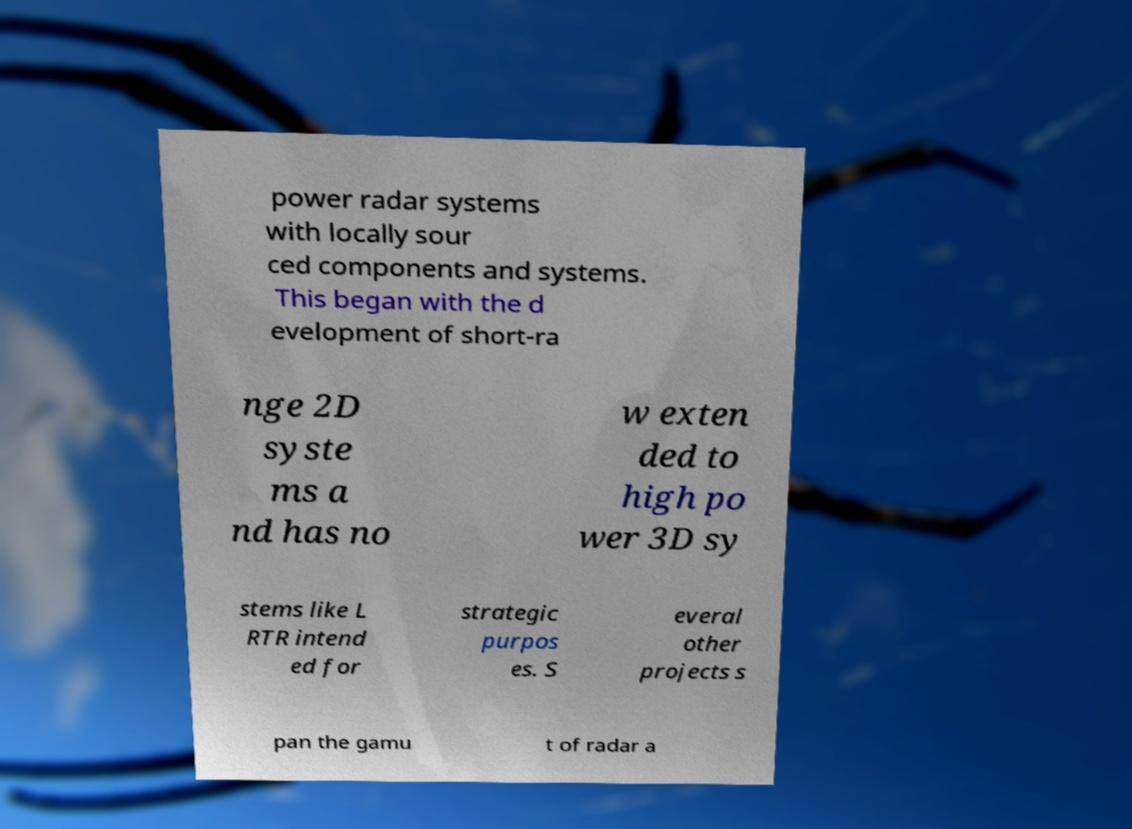What messages or text are displayed in this image? I need them in a readable, typed format. power radar systems with locally sour ced components and systems. This began with the d evelopment of short-ra nge 2D syste ms a nd has no w exten ded to high po wer 3D sy stems like L RTR intend ed for strategic purpos es. S everal other projects s pan the gamu t of radar a 